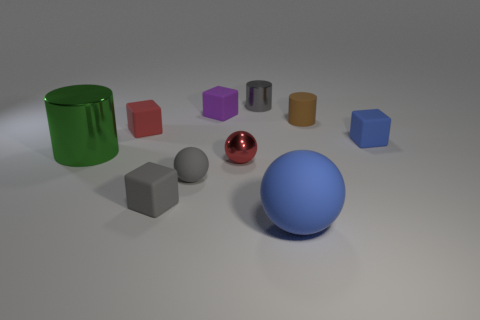Subtract all small gray cylinders. How many cylinders are left? 2 Subtract all purple cubes. Subtract all purple cylinders. How many cubes are left? 3 Subtract all brown cylinders. How many cyan blocks are left? 0 Subtract all metal cylinders. Subtract all big cyan metallic balls. How many objects are left? 8 Add 1 gray cubes. How many gray cubes are left? 2 Add 3 small red blocks. How many small red blocks exist? 4 Subtract all gray cubes. How many cubes are left? 3 Subtract 0 red cylinders. How many objects are left? 10 Subtract all blocks. How many objects are left? 6 Subtract 2 cubes. How many cubes are left? 2 